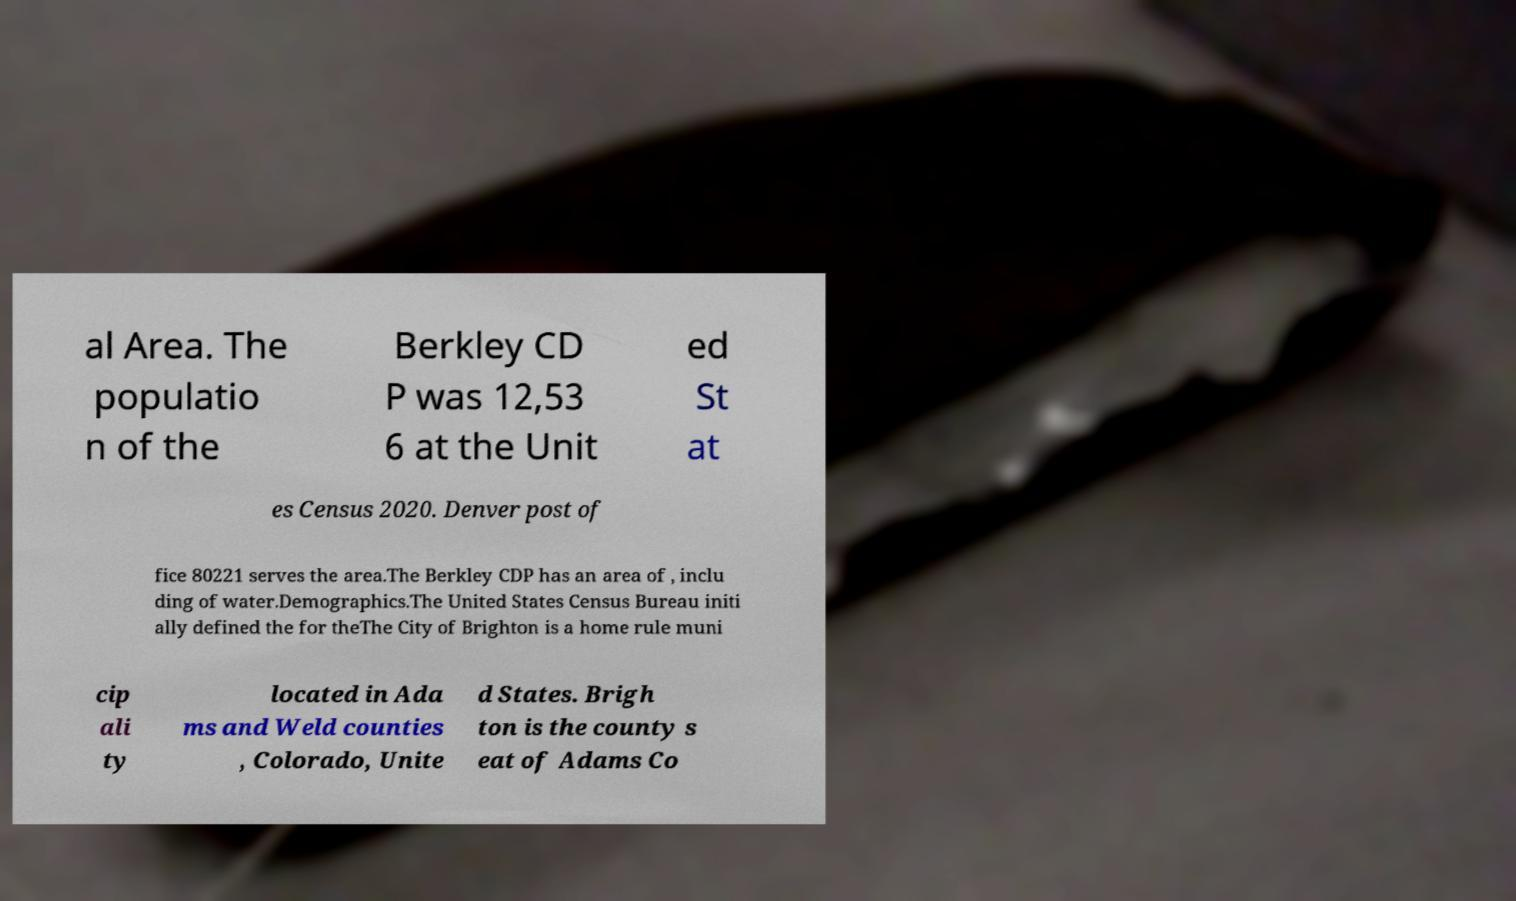I need the written content from this picture converted into text. Can you do that? al Area. The populatio n of the Berkley CD P was 12,53 6 at the Unit ed St at es Census 2020. Denver post of fice 80221 serves the area.The Berkley CDP has an area of , inclu ding of water.Demographics.The United States Census Bureau initi ally defined the for theThe City of Brighton is a home rule muni cip ali ty located in Ada ms and Weld counties , Colorado, Unite d States. Brigh ton is the county s eat of Adams Co 